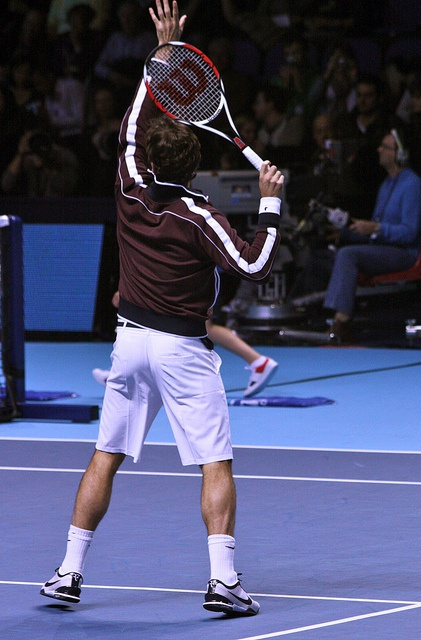Describe the objects in this image and their specific colors. I can see people in black, lavender, violet, and maroon tones, people in black, navy, maroon, and gray tones, tennis racket in black, gray, lavender, and maroon tones, people in black, maroon, and purple tones, and people in black, gray, and pink tones in this image. 